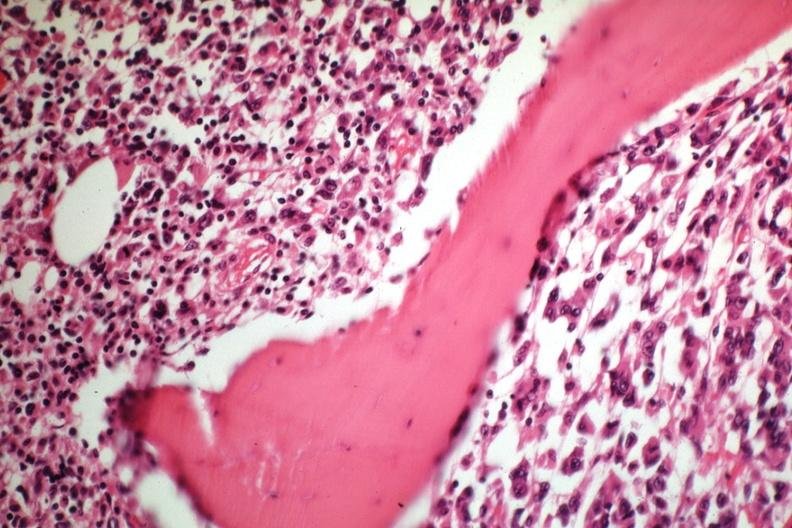s view looking down on heads present?
Answer the question using a single word or phrase. No 